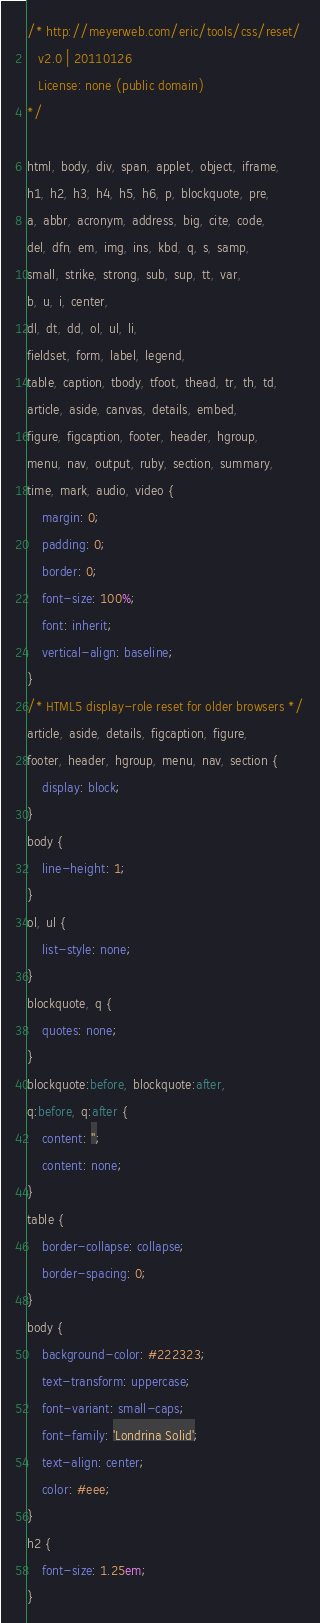Convert code to text. <code><loc_0><loc_0><loc_500><loc_500><_CSS_>/* http://meyerweb.com/eric/tools/css/reset/ 
   v2.0 | 20110126
   License: none (public domain)
*/

html, body, div, span, applet, object, iframe,
h1, h2, h3, h4, h5, h6, p, blockquote, pre,
a, abbr, acronym, address, big, cite, code,
del, dfn, em, img, ins, kbd, q, s, samp,
small, strike, strong, sub, sup, tt, var,
b, u, i, center,
dl, dt, dd, ol, ul, li,
fieldset, form, label, legend,
table, caption, tbody, tfoot, thead, tr, th, td,
article, aside, canvas, details, embed, 
figure, figcaption, footer, header, hgroup, 
menu, nav, output, ruby, section, summary,
time, mark, audio, video {
	margin: 0;
	padding: 0;
	border: 0;
	font-size: 100%;
	font: inherit;
	vertical-align: baseline;
}
/* HTML5 display-role reset for older browsers */
article, aside, details, figcaption, figure, 
footer, header, hgroup, menu, nav, section {
	display: block;
}
body {
	line-height: 1;
}
ol, ul {
	list-style: none;
}
blockquote, q {
	quotes: none;
}
blockquote:before, blockquote:after,
q:before, q:after {
	content: '';
	content: none;
}
table {
	border-collapse: collapse;
	border-spacing: 0;
}
body { 
    background-color: #222323;
    text-transform: uppercase;
    font-variant: small-caps; 
    font-family: 'Londrina Solid';
    text-align: center;
    color: #eee;
}
h2 {
    font-size: 1.25em;
}</code> 